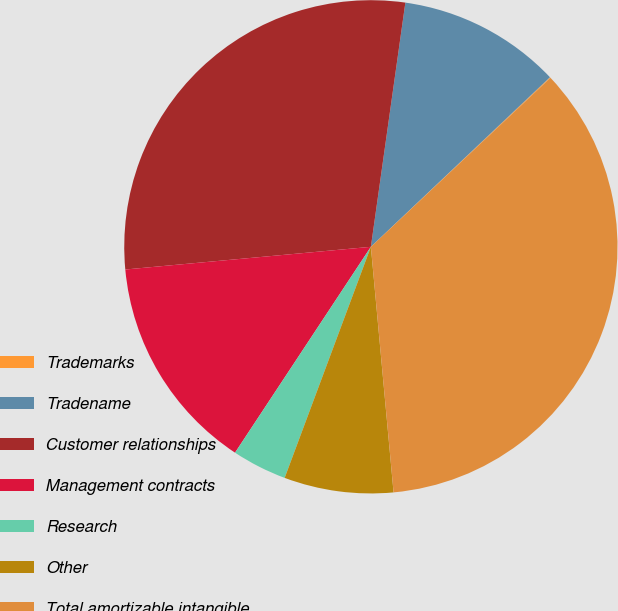Convert chart. <chart><loc_0><loc_0><loc_500><loc_500><pie_chart><fcel>Trademarks<fcel>Tradename<fcel>Customer relationships<fcel>Management contracts<fcel>Research<fcel>Other<fcel>Total amortizable intangible<nl><fcel>0.05%<fcel>10.7%<fcel>28.7%<fcel>14.25%<fcel>3.6%<fcel>7.15%<fcel>35.55%<nl></chart> 